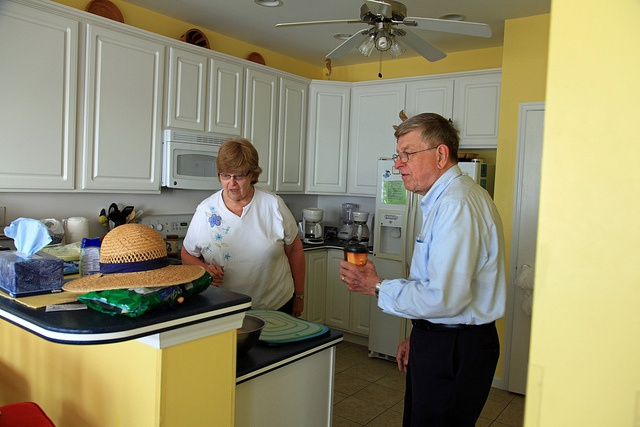Describe the objects in this image and their specific colors. I can see people in gray, black, darkgray, and lightblue tones, people in gray, darkgray, lavender, and maroon tones, refrigerator in gray, darkgray, and green tones, microwave in gray, darkgray, lightgray, and lightblue tones, and oven in gray and black tones in this image. 